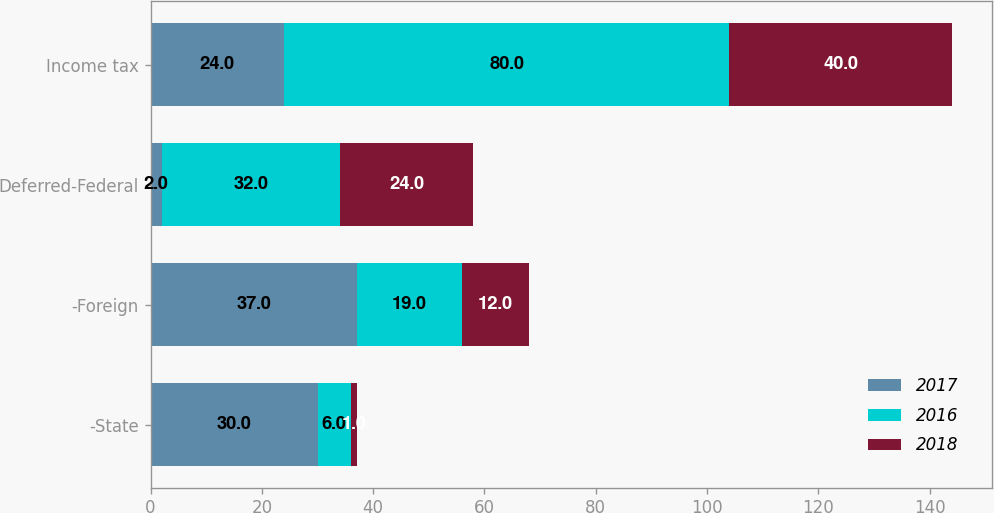Convert chart. <chart><loc_0><loc_0><loc_500><loc_500><stacked_bar_chart><ecel><fcel>-State<fcel>-Foreign<fcel>Deferred-Federal<fcel>Income tax<nl><fcel>2017<fcel>30<fcel>37<fcel>2<fcel>24<nl><fcel>2016<fcel>6<fcel>19<fcel>32<fcel>80<nl><fcel>2018<fcel>1<fcel>12<fcel>24<fcel>40<nl></chart> 